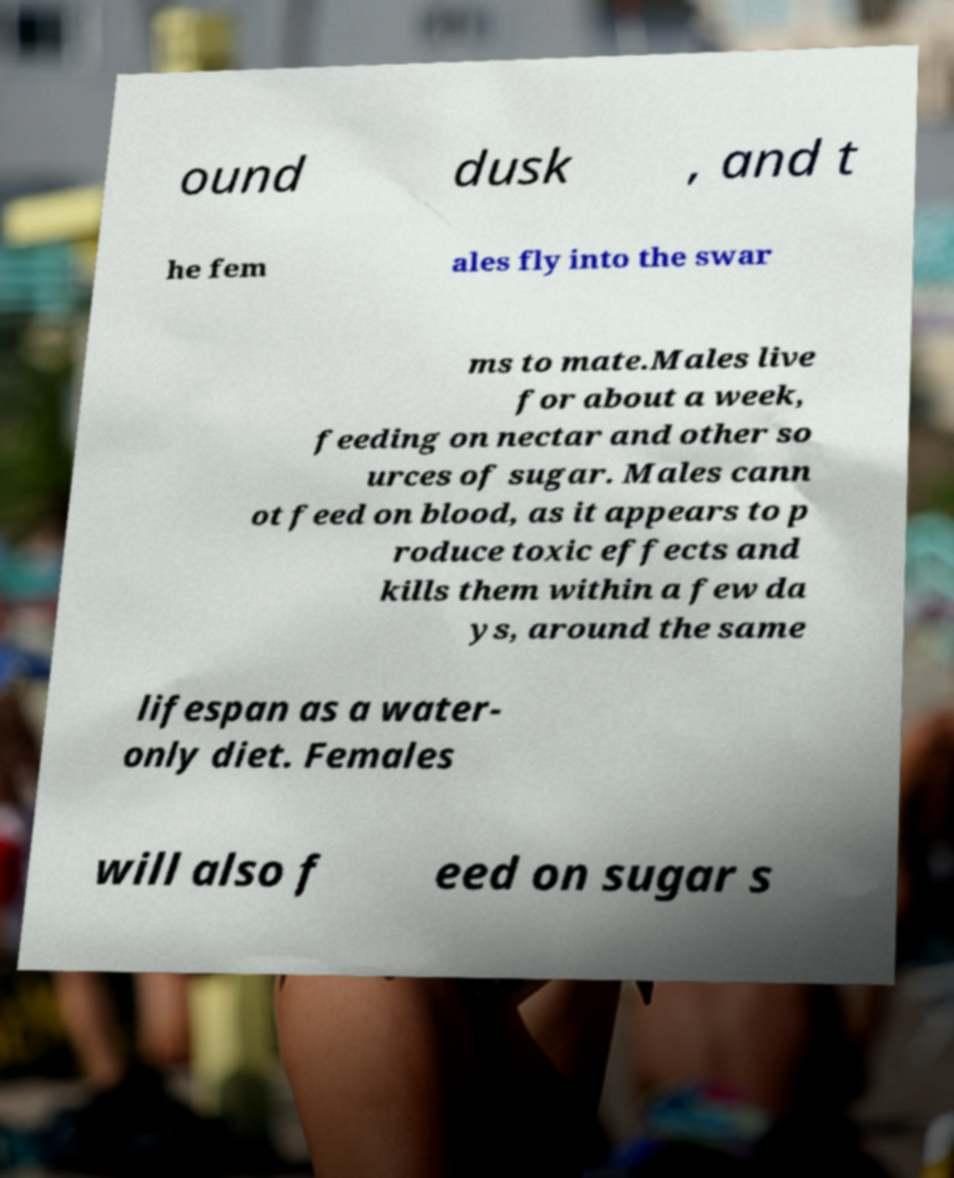Can you accurately transcribe the text from the provided image for me? ound dusk , and t he fem ales fly into the swar ms to mate.Males live for about a week, feeding on nectar and other so urces of sugar. Males cann ot feed on blood, as it appears to p roduce toxic effects and kills them within a few da ys, around the same lifespan as a water- only diet. Females will also f eed on sugar s 